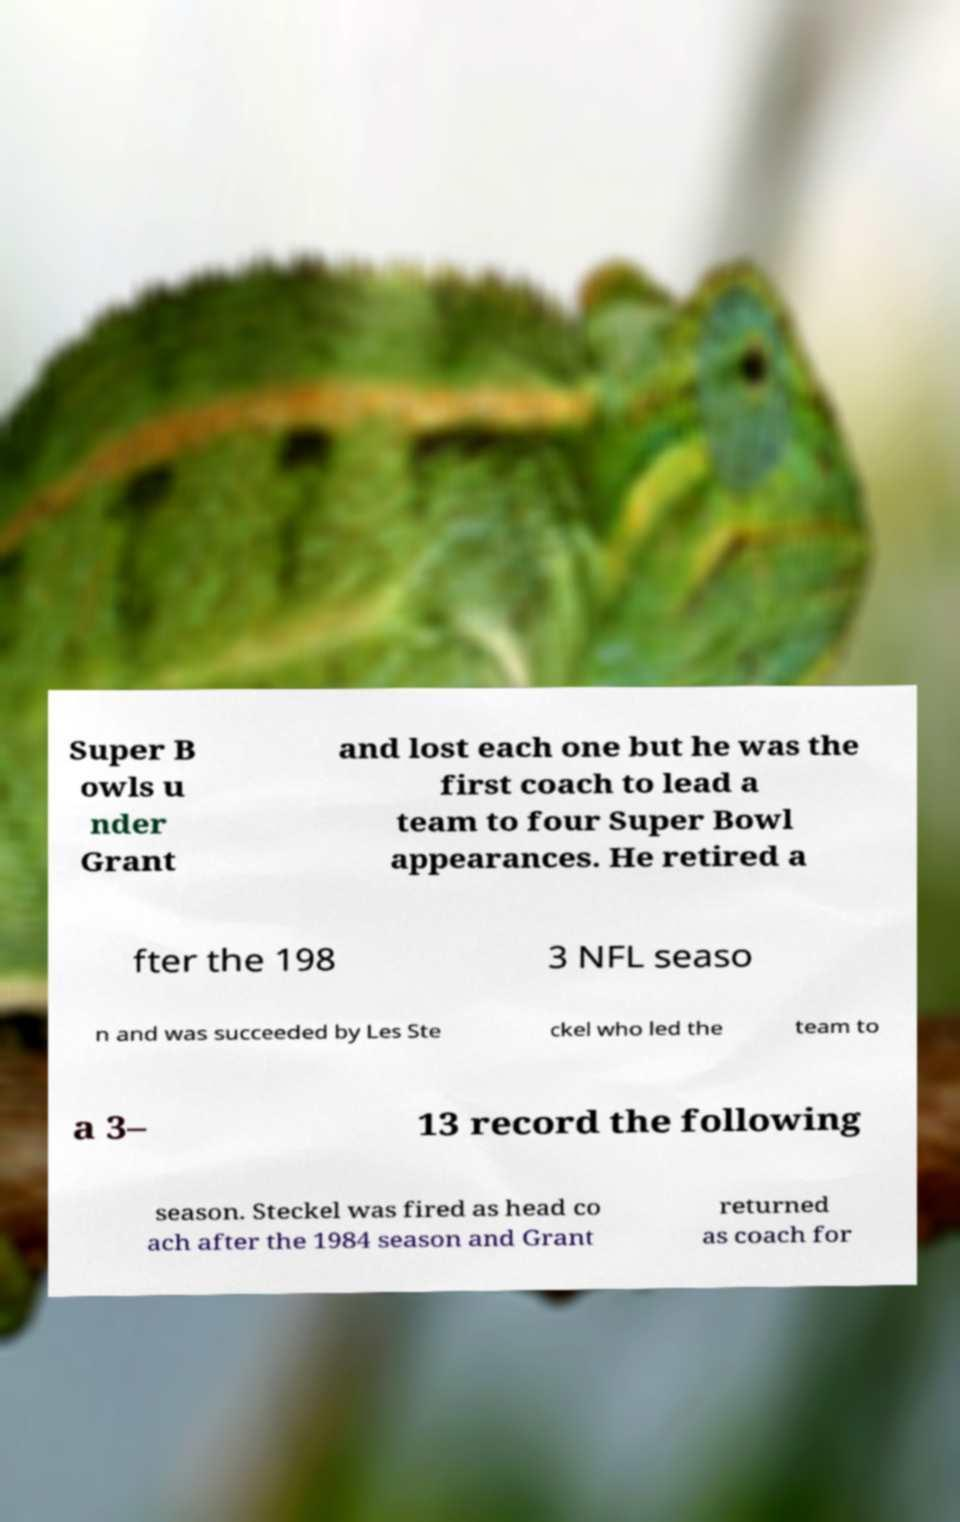Please read and relay the text visible in this image. What does it say? Super B owls u nder Grant and lost each one but he was the first coach to lead a team to four Super Bowl appearances. He retired a fter the 198 3 NFL seaso n and was succeeded by Les Ste ckel who led the team to a 3– 13 record the following season. Steckel was fired as head co ach after the 1984 season and Grant returned as coach for 